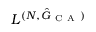<formula> <loc_0><loc_0><loc_500><loc_500>L ^ { ( N , \hat { G } _ { C A } ) }</formula> 